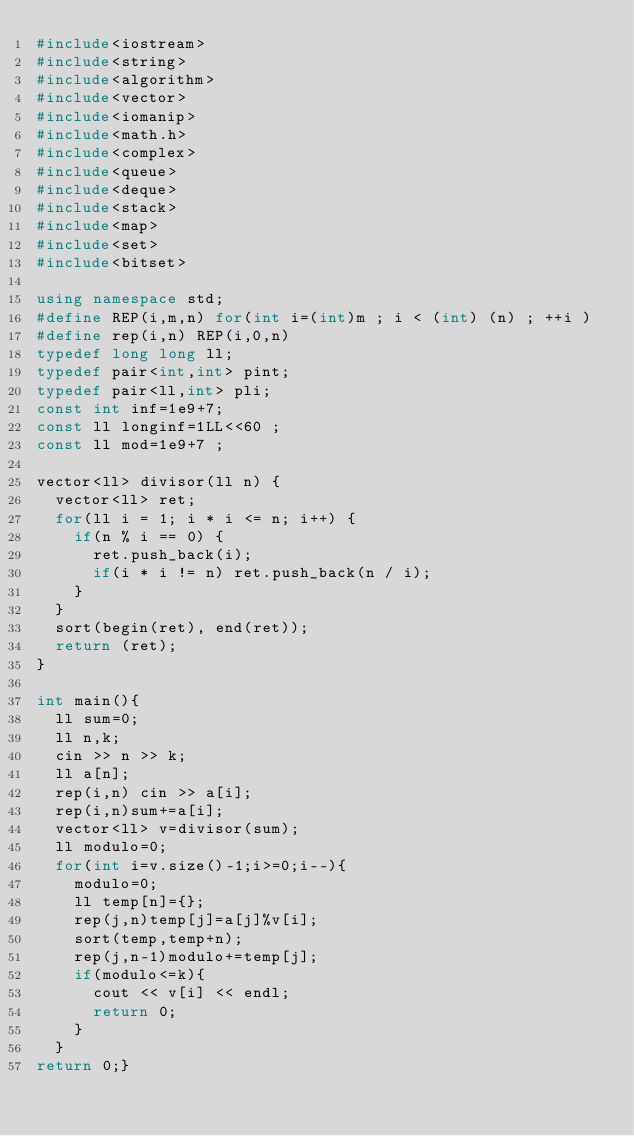Convert code to text. <code><loc_0><loc_0><loc_500><loc_500><_C++_>#include<iostream>
#include<string>
#include<algorithm>
#include<vector>
#include<iomanip>
#include<math.h>
#include<complex>
#include<queue>
#include<deque>
#include<stack>
#include<map>
#include<set>
#include<bitset>

using namespace std;
#define REP(i,m,n) for(int i=(int)m ; i < (int) (n) ; ++i )
#define rep(i,n) REP(i,0,n)
typedef long long ll;
typedef pair<int,int> pint;
typedef pair<ll,int> pli;
const int inf=1e9+7;
const ll longinf=1LL<<60 ;
const ll mod=1e9+7 ;

vector<ll> divisor(ll n) {
  vector<ll> ret;
  for(ll i = 1; i * i <= n; i++) {
    if(n % i == 0) {
      ret.push_back(i);
      if(i * i != n) ret.push_back(n / i);
    }
  }
  sort(begin(ret), end(ret));
  return (ret);
}

int main(){
  ll sum=0;
  ll n,k;
  cin >> n >> k;
  ll a[n];
  rep(i,n) cin >> a[i];
  rep(i,n)sum+=a[i];
  vector<ll> v=divisor(sum);
  ll modulo=0;
  for(int i=v.size()-1;i>=0;i--){
    modulo=0;
    ll temp[n]={};
    rep(j,n)temp[j]=a[j]%v[i];
    sort(temp,temp+n);
    rep(j,n-1)modulo+=temp[j];
    if(modulo<=k){
      cout << v[i] << endl;
      return 0;
    }
  }
return 0;}</code> 